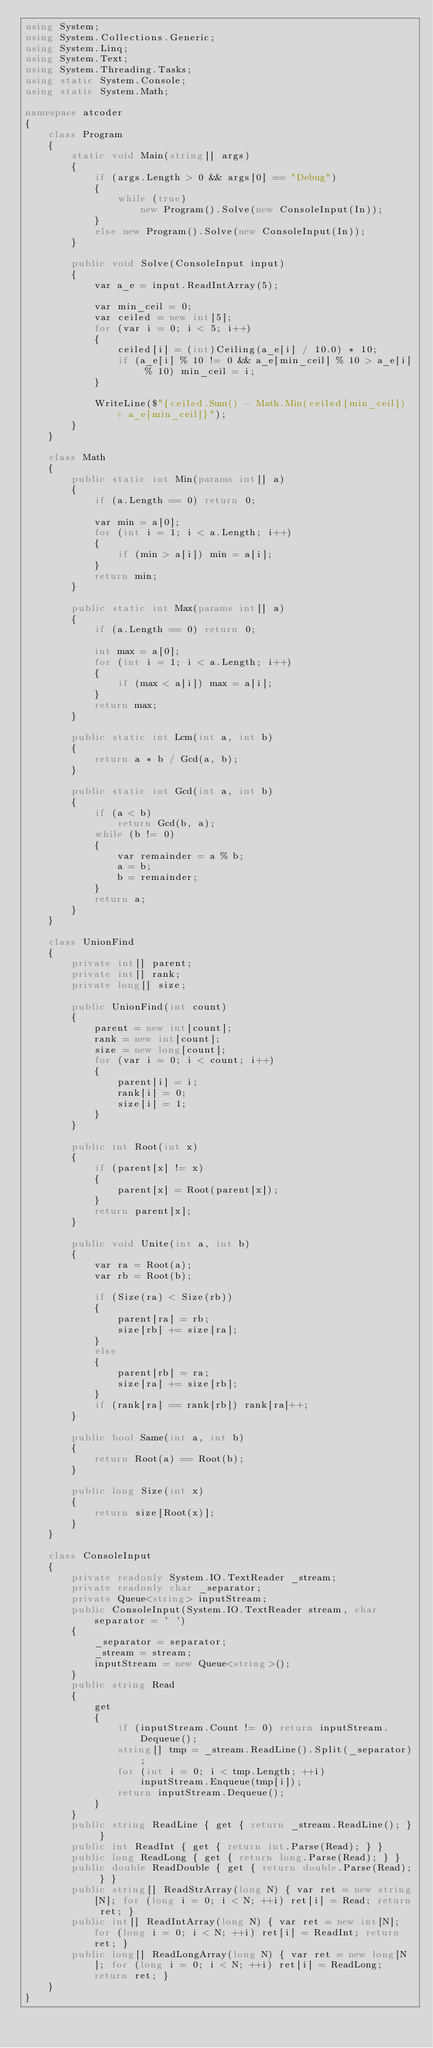Convert code to text. <code><loc_0><loc_0><loc_500><loc_500><_C#_>using System;
using System.Collections.Generic;
using System.Linq;
using System.Text;
using System.Threading.Tasks;
using static System.Console;
using static System.Math;

namespace atcoder
{
    class Program
    {
        static void Main(string[] args)
        {
            if (args.Length > 0 && args[0] == "Debug")
            {
                while (true)
                    new Program().Solve(new ConsoleInput(In));
            }
            else new Program().Solve(new ConsoleInput(In));
        }

        public void Solve(ConsoleInput input)
        {
            var a_e = input.ReadIntArray(5);

            var min_ceil = 0;
            var ceiled = new int[5];
            for (var i = 0; i < 5; i++)
            {
                ceiled[i] = (int)Ceiling(a_e[i] / 10.0) * 10;
                if (a_e[i] % 10 != 0 && a_e[min_ceil] % 10 > a_e[i] % 10) min_ceil = i;
            }

            WriteLine($"{ceiled.Sum() - Math.Min(ceiled[min_ceil]) + a_e[min_ceil]}");
        }
    }

    class Math
    {
        public static int Min(params int[] a)
        {
            if (a.Length == 0) return 0;

            var min = a[0];
            for (int i = 1; i < a.Length; i++)
            {
                if (min > a[i]) min = a[i];
            }
            return min;
        }

        public static int Max(params int[] a)
        {
            if (a.Length == 0) return 0;

            int max = a[0];
            for (int i = 1; i < a.Length; i++)
            {
                if (max < a[i]) max = a[i];
            }
            return max;
        }

        public static int Lcm(int a, int b)
        {
            return a * b / Gcd(a, b);
        }

        public static int Gcd(int a, int b)
        {
            if (a < b)
                return Gcd(b, a);
            while (b != 0)
            {
                var remainder = a % b;
                a = b;
                b = remainder;
            }
            return a;
        }
    }

    class UnionFind
    {
        private int[] parent;
        private int[] rank;
        private long[] size;

        public UnionFind(int count)
        {
            parent = new int[count];
            rank = new int[count];
            size = new long[count];
            for (var i = 0; i < count; i++)
            {
                parent[i] = i;
                rank[i] = 0;
                size[i] = 1;
            }
        }

        public int Root(int x)
        {
            if (parent[x] != x)
            {
                parent[x] = Root(parent[x]);
            }
            return parent[x];
        }

        public void Unite(int a, int b)
        {
            var ra = Root(a);
            var rb = Root(b);

            if (Size(ra) < Size(rb))
            {
                parent[ra] = rb;
                size[rb] += size[ra];
            }
            else
            {
                parent[rb] = ra;
                size[ra] += size[rb];
            }
            if (rank[ra] == rank[rb]) rank[ra]++;
        }

        public bool Same(int a, int b)
        {
            return Root(a) == Root(b);
        }

        public long Size(int x)
        {
            return size[Root(x)];
        }
    }

    class ConsoleInput
    {
        private readonly System.IO.TextReader _stream;
        private readonly char _separator;
        private Queue<string> inputStream;
        public ConsoleInput(System.IO.TextReader stream, char separator = ' ')
        {
            _separator = separator;
            _stream = stream;
            inputStream = new Queue<string>();
        }
        public string Read
        {
            get
            {
                if (inputStream.Count != 0) return inputStream.Dequeue();
                string[] tmp = _stream.ReadLine().Split(_separator);
                for (int i = 0; i < tmp.Length; ++i)
                    inputStream.Enqueue(tmp[i]);
                return inputStream.Dequeue();
            }
        }
        public string ReadLine { get { return _stream.ReadLine(); } }
        public int ReadInt { get { return int.Parse(Read); } }
        public long ReadLong { get { return long.Parse(Read); } }
        public double ReadDouble { get { return double.Parse(Read); } }
        public string[] ReadStrArray(long N) { var ret = new string[N]; for (long i = 0; i < N; ++i) ret[i] = Read; return ret; }
        public int[] ReadIntArray(long N) { var ret = new int[N]; for (long i = 0; i < N; ++i) ret[i] = ReadInt; return ret; }
        public long[] ReadLongArray(long N) { var ret = new long[N]; for (long i = 0; i < N; ++i) ret[i] = ReadLong; return ret; }
    }
}
</code> 